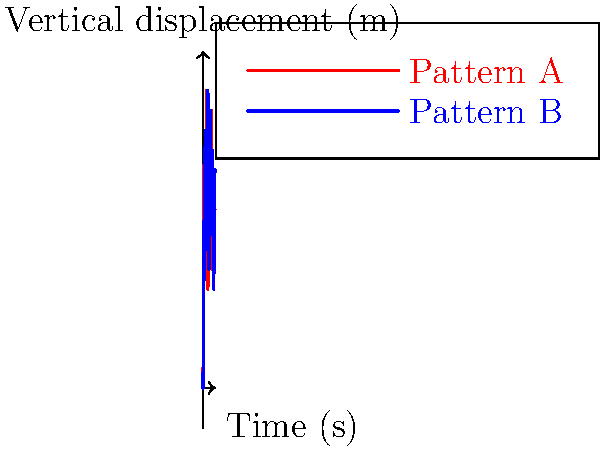As a cloud service provider representative, you're showcasing your platform's capabilities for biomechanics research. The graph above displays two gait patterns (A and B) using motion capture data visualization. Which pattern exhibits greater variability in vertical displacement, and how might this information be valuable for researchers using your cloud platform? To determine which gait pattern shows greater variability in vertical displacement, we need to analyze the data presented in the graph:

1. Observe the overall range:
   - Pattern A (red) ranges approximately from 0.5 to 1.5 meters.
   - Pattern B (blue) ranges approximately from 0.5 to 1.5 meters as well.

2. Analyze the frequency of peaks and troughs:
   - Pattern A has more frequent alternations between high and low points.
   - Pattern B shows smoother transitions and fewer extreme changes.

3. Calculate the standard deviation (if exact data were available):
   - A higher standard deviation would indicate greater variability.
   - Based on visual inspection, Pattern A would likely have a higher standard deviation.

4. Interpret the results:
   - Pattern A exhibits greater variability in vertical displacement due to its more frequent and abrupt changes.

5. Value for researchers using the cloud platform:
   - Researchers can use this data to:
     a) Identify potential gait abnormalities or inefficiencies.
     b) Compare pre- and post-intervention gait patterns.
     c) Develop personalized treatment plans for patients with gait disorders.
   - The cloud platform can provide:
     a) Powerful computing resources for complex gait analysis algorithms.
     b) Secure storage for large motion capture datasets.
     c) Collaborative tools for sharing and analyzing results among research teams.
     d) Scalability for processing data from multiple subjects or longitudinal studies.
Answer: Pattern A shows greater variability; valuable for identifying gait abnormalities, comparing interventions, and developing treatments using cloud computing power and collaborative tools. 